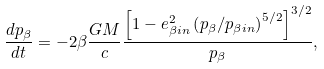<formula> <loc_0><loc_0><loc_500><loc_500>\frac { d p _ { \beta } } { d t } = - 2 \beta \frac { G M } { c } \frac { \left [ 1 - e _ { \beta i n } ^ { 2 } \left ( p _ { \beta } / p _ { \beta i n } \right ) ^ { 5 / 2 } \right ] ^ { 3 / 2 } } { p _ { \beta } } ,</formula> 